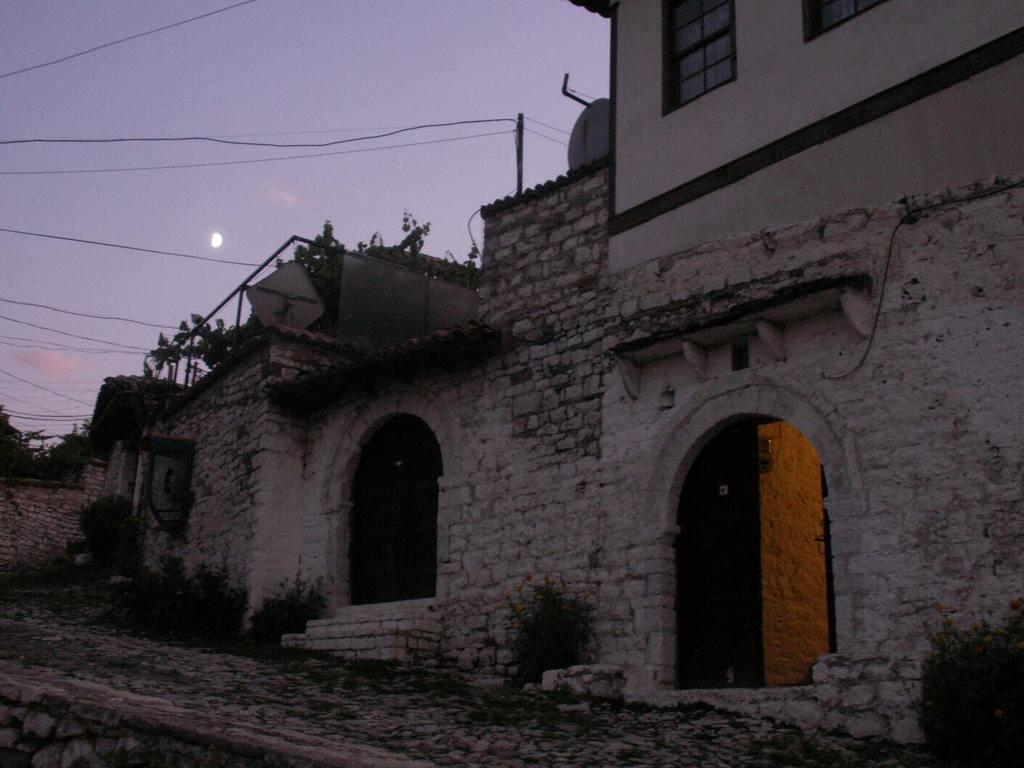What type of terrain do the houses in the image appear to be built on? The houses in the image are built on a slope surface. What features can be seen on the houses? The houses have doors and windows. What can be seen in the background of the image? The sky is visible behind the houses. What celestial body is present in the sky? There is a moon in the sky. What atmospheric phenomenon can be observed in the sky? Clouds are present in the sky. Where is the lake located in the image? There is no lake present in the image. What type of recess can be seen in the houses in the image? There is no recess visible in the houses in the image. 